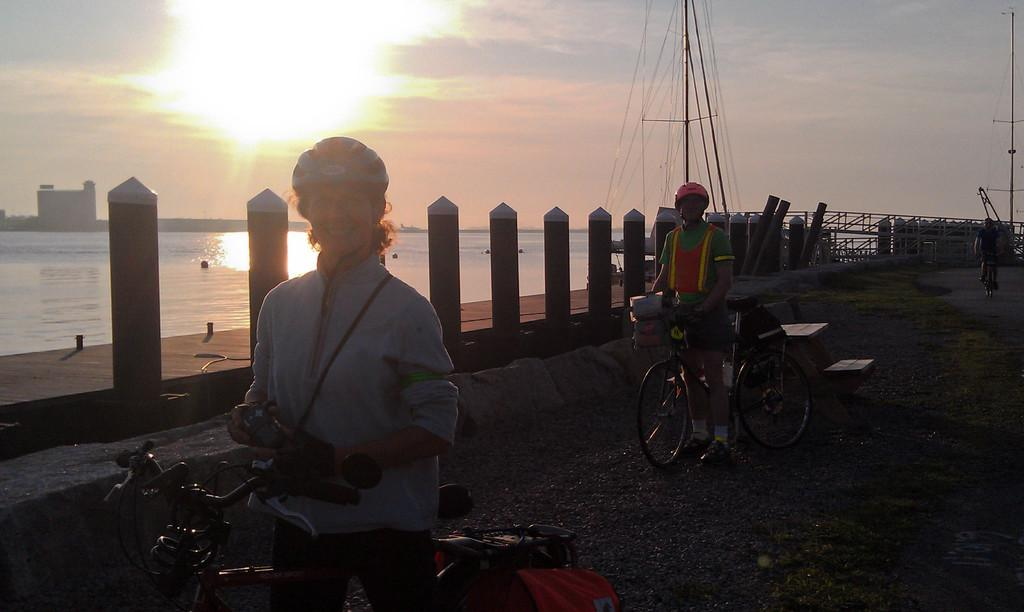How many people are in the image? There are two people in the image. What are the people doing in the image? The people are with bicycles. What can be seen in the background of the image? There is water and the sky visible in the background of the image. What type of cake is being served after the bicycle race in the image? There is no cake or bicycle race present in the image. 